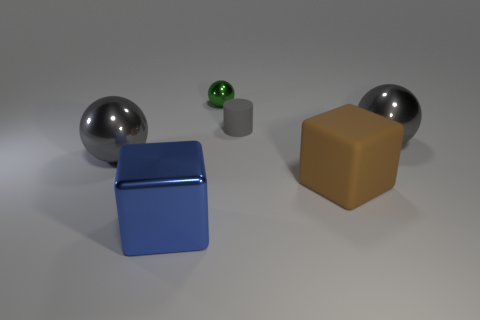Subtract all gray balls. How many balls are left? 1 Add 3 large blue matte blocks. How many objects exist? 9 Subtract all cylinders. How many objects are left? 5 Subtract all big blocks. Subtract all green objects. How many objects are left? 3 Add 4 big blue blocks. How many big blue blocks are left? 5 Add 6 green things. How many green things exist? 7 Subtract 0 purple spheres. How many objects are left? 6 